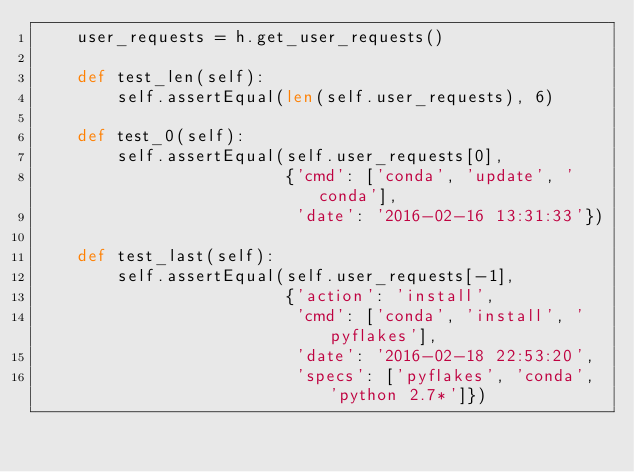<code> <loc_0><loc_0><loc_500><loc_500><_Python_>    user_requests = h.get_user_requests()

    def test_len(self):
        self.assertEqual(len(self.user_requests), 6)

    def test_0(self):
        self.assertEqual(self.user_requests[0],
                         {'cmd': ['conda', 'update', 'conda'],
                          'date': '2016-02-16 13:31:33'})

    def test_last(self):
        self.assertEqual(self.user_requests[-1],
                         {'action': 'install',
                          'cmd': ['conda', 'install', 'pyflakes'],
                          'date': '2016-02-18 22:53:20',
                          'specs': ['pyflakes', 'conda', 'python 2.7*']})
</code> 